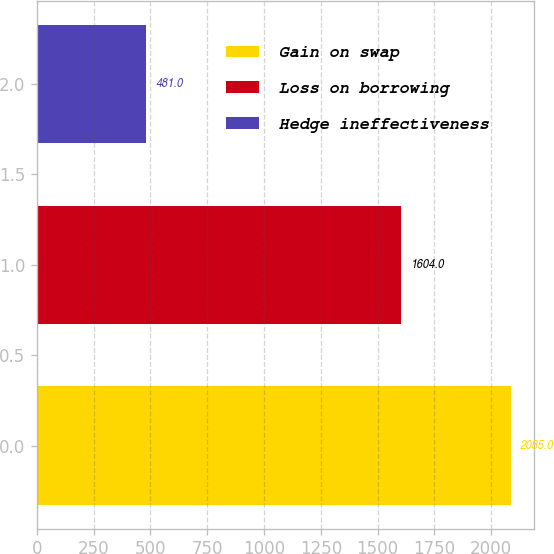Convert chart to OTSL. <chart><loc_0><loc_0><loc_500><loc_500><bar_chart><fcel>Gain on swap<fcel>Loss on borrowing<fcel>Hedge ineffectiveness<nl><fcel>2085<fcel>1604<fcel>481<nl></chart> 